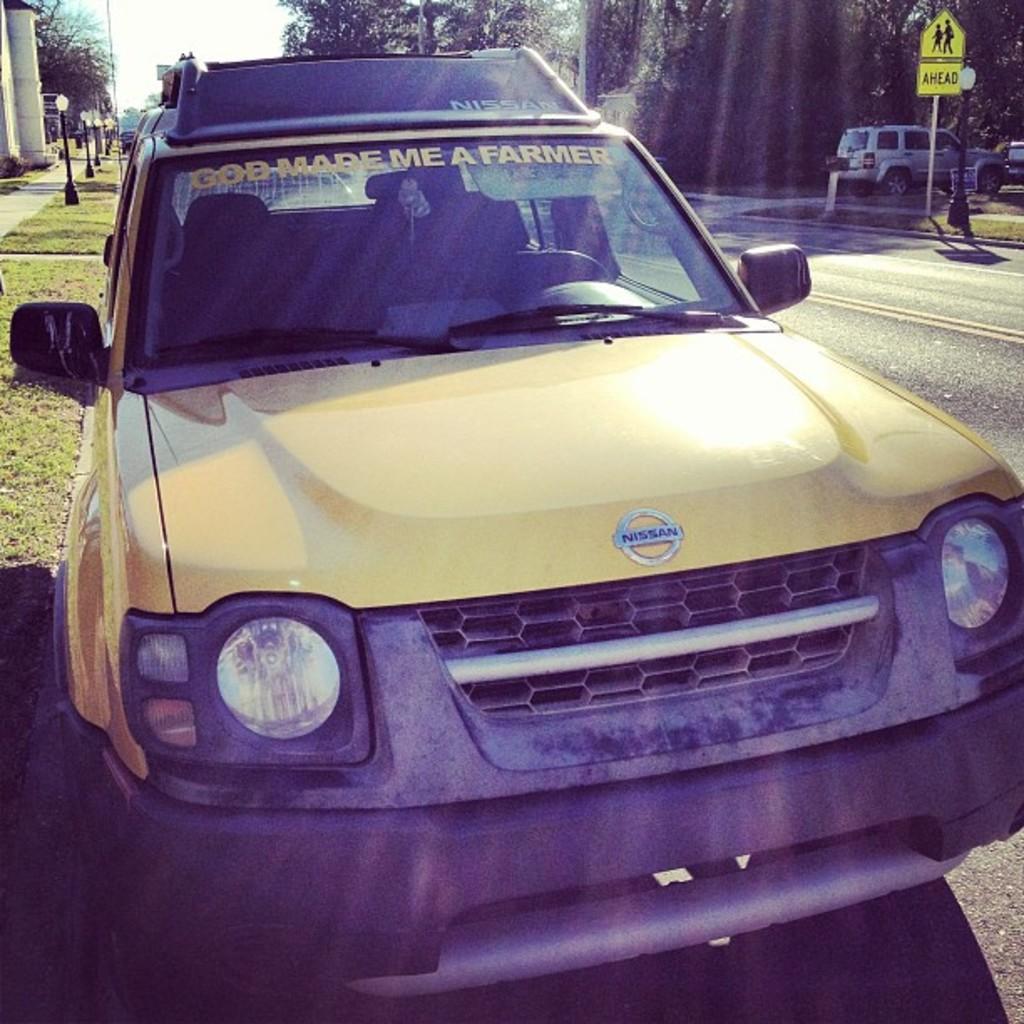How would you summarize this image in a sentence or two? This is an outside view. Here I can see a car on the road. On the left side, I can see the grass, few light poles and a building. On the right side there is another car and few poles. In the background there are many trees. 